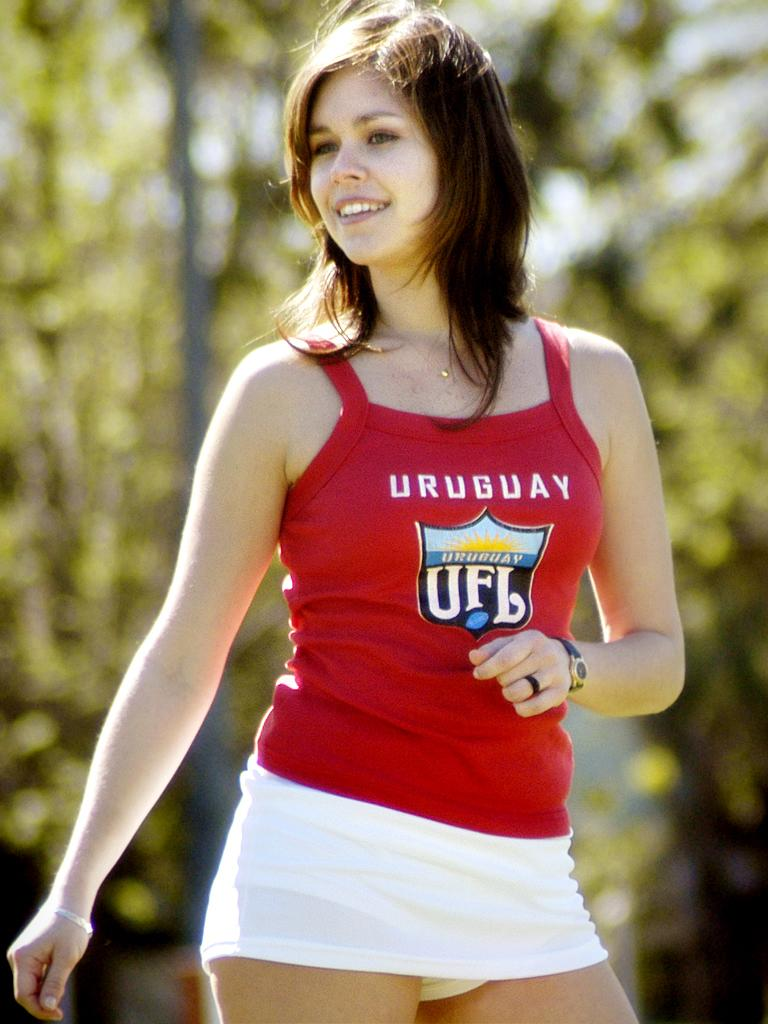<image>
Write a terse but informative summary of the picture. A girl wearing a white skirt and a red shirt that says Uruguay. 